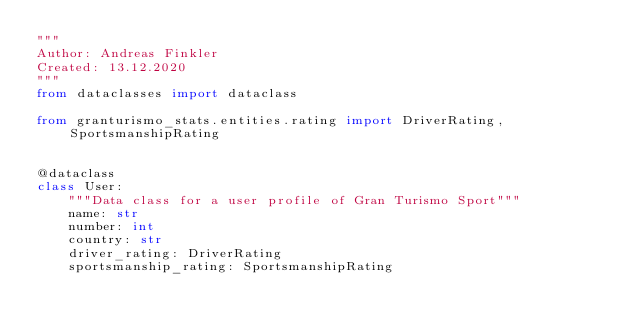<code> <loc_0><loc_0><loc_500><loc_500><_Python_>"""
Author: Andreas Finkler
Created: 13.12.2020
"""
from dataclasses import dataclass

from granturismo_stats.entities.rating import DriverRating, SportsmanshipRating


@dataclass
class User:
    """Data class for a user profile of Gran Turismo Sport"""
    name: str
    number: int
    country: str
    driver_rating: DriverRating
    sportsmanship_rating: SportsmanshipRating
</code> 